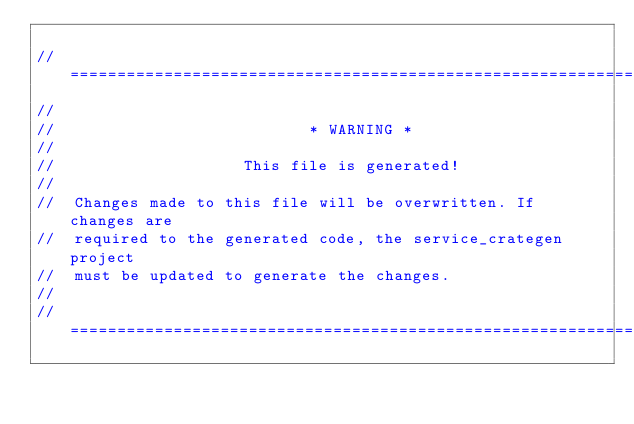Convert code to text. <code><loc_0><loc_0><loc_500><loc_500><_Rust_>
// =================================================================
//
//                           * WARNING *
//
//                    This file is generated!
//
//  Changes made to this file will be overwritten. If changes are
//  required to the generated code, the service_crategen project
//  must be updated to generate the changes.
//
// =================================================================
</code> 